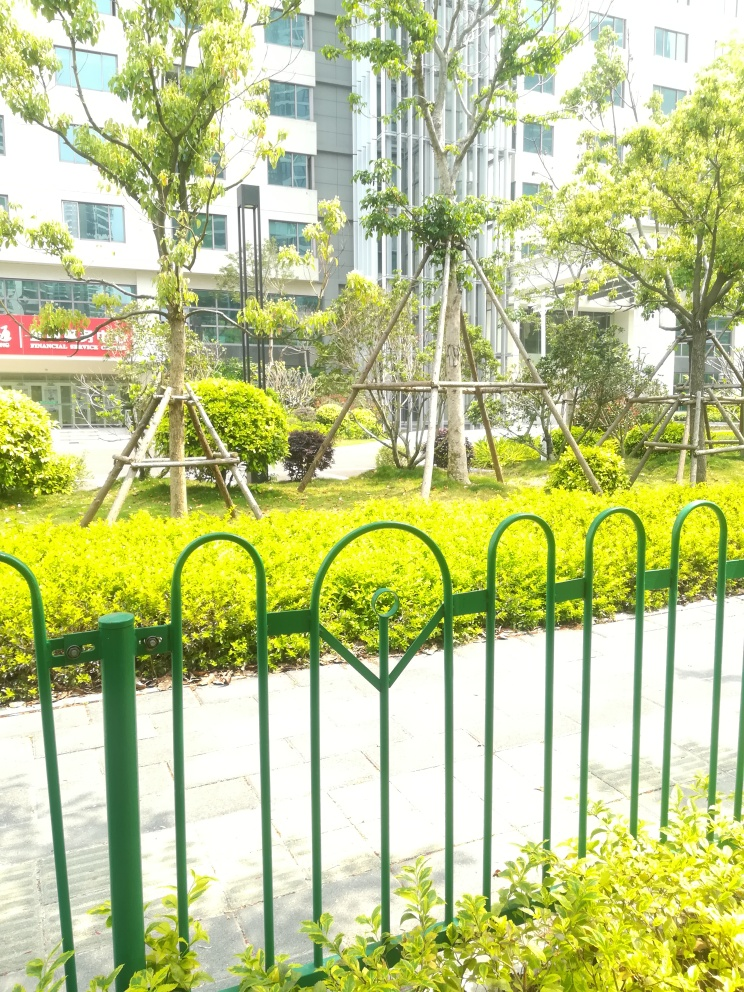Can you describe the style and possible materials of the fence shown in the image? The fence in the image has a vertical bar design with a traditional decorative motif at the top, often called fleur-de-lis. The materials appear to be metal, most likely steel, painted in green to blend with the natural environment. The bars are evenly spaced, providing both aesthetic appeal and functional security while allowing for a clear view of the garden behind it. 